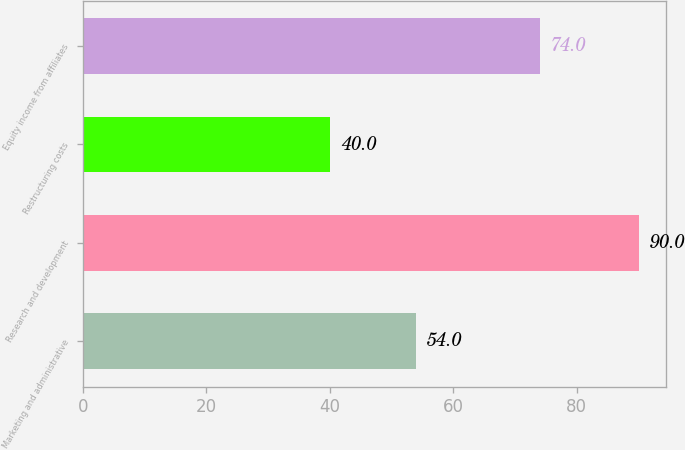<chart> <loc_0><loc_0><loc_500><loc_500><bar_chart><fcel>Marketing and administrative<fcel>Research and development<fcel>Restructuring costs<fcel>Equity income from affiliates<nl><fcel>54<fcel>90<fcel>40<fcel>74<nl></chart> 